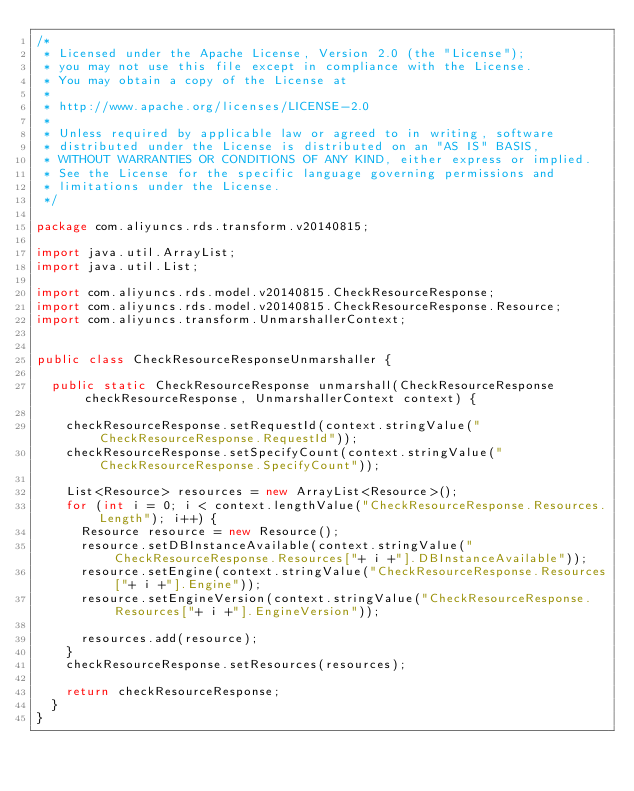Convert code to text. <code><loc_0><loc_0><loc_500><loc_500><_Java_>/*
 * Licensed under the Apache License, Version 2.0 (the "License");
 * you may not use this file except in compliance with the License.
 * You may obtain a copy of the License at
 *
 * http://www.apache.org/licenses/LICENSE-2.0
 *
 * Unless required by applicable law or agreed to in writing, software
 * distributed under the License is distributed on an "AS IS" BASIS,
 * WITHOUT WARRANTIES OR CONDITIONS OF ANY KIND, either express or implied.
 * See the License for the specific language governing permissions and
 * limitations under the License.
 */

package com.aliyuncs.rds.transform.v20140815;

import java.util.ArrayList;
import java.util.List;

import com.aliyuncs.rds.model.v20140815.CheckResourceResponse;
import com.aliyuncs.rds.model.v20140815.CheckResourceResponse.Resource;
import com.aliyuncs.transform.UnmarshallerContext;


public class CheckResourceResponseUnmarshaller {

	public static CheckResourceResponse unmarshall(CheckResourceResponse checkResourceResponse, UnmarshallerContext context) {
		
		checkResourceResponse.setRequestId(context.stringValue("CheckResourceResponse.RequestId"));
		checkResourceResponse.setSpecifyCount(context.stringValue("CheckResourceResponse.SpecifyCount"));

		List<Resource> resources = new ArrayList<Resource>();
		for (int i = 0; i < context.lengthValue("CheckResourceResponse.Resources.Length"); i++) {
			Resource resource = new Resource();
			resource.setDBInstanceAvailable(context.stringValue("CheckResourceResponse.Resources["+ i +"].DBInstanceAvailable"));
			resource.setEngine(context.stringValue("CheckResourceResponse.Resources["+ i +"].Engine"));
			resource.setEngineVersion(context.stringValue("CheckResourceResponse.Resources["+ i +"].EngineVersion"));

			resources.add(resource);
		}
		checkResourceResponse.setResources(resources);
	 
	 	return checkResourceResponse;
	}
}</code> 